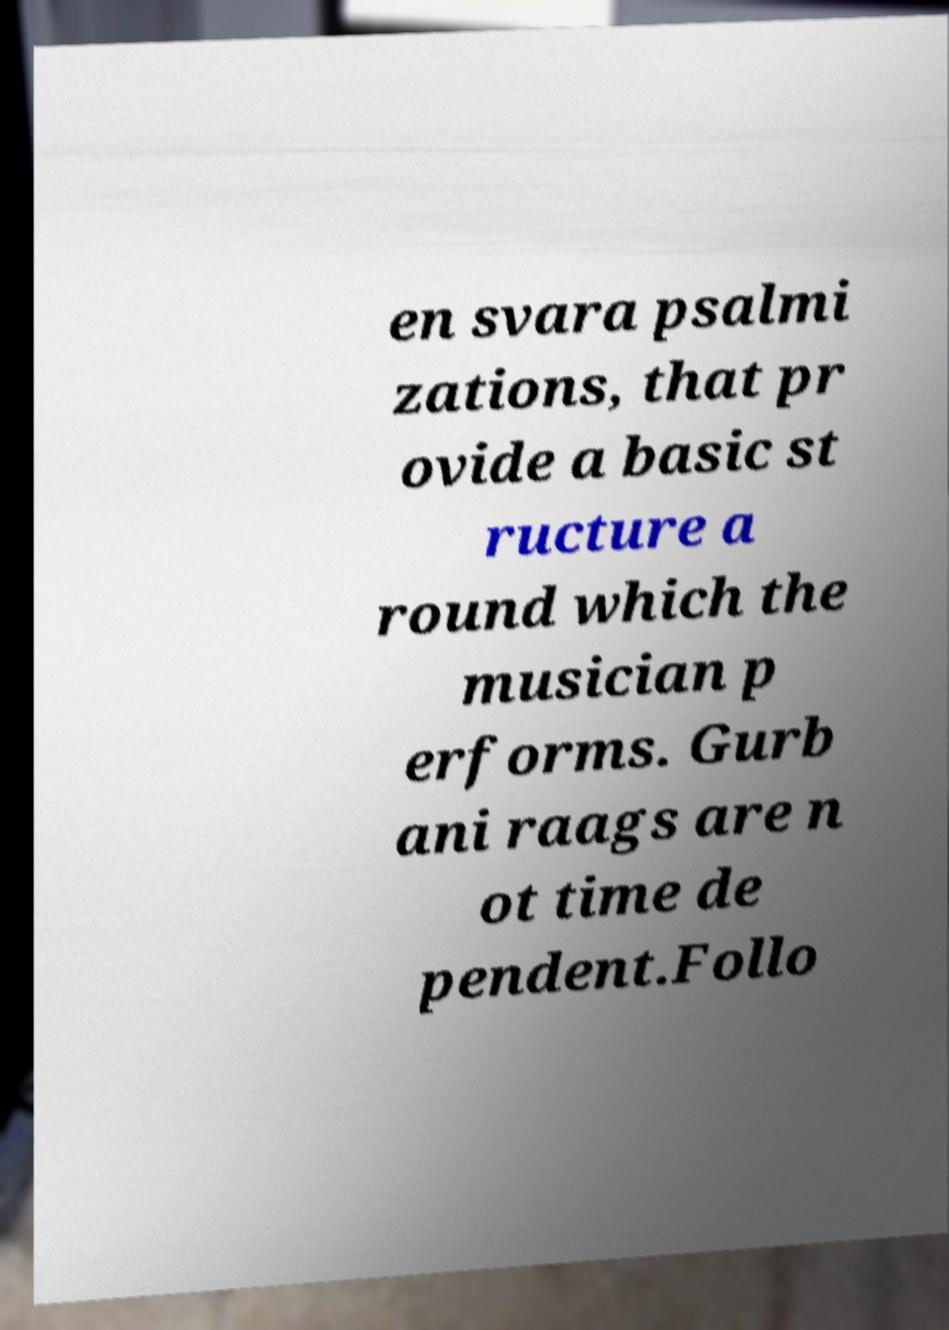For documentation purposes, I need the text within this image transcribed. Could you provide that? en svara psalmi zations, that pr ovide a basic st ructure a round which the musician p erforms. Gurb ani raags are n ot time de pendent.Follo 